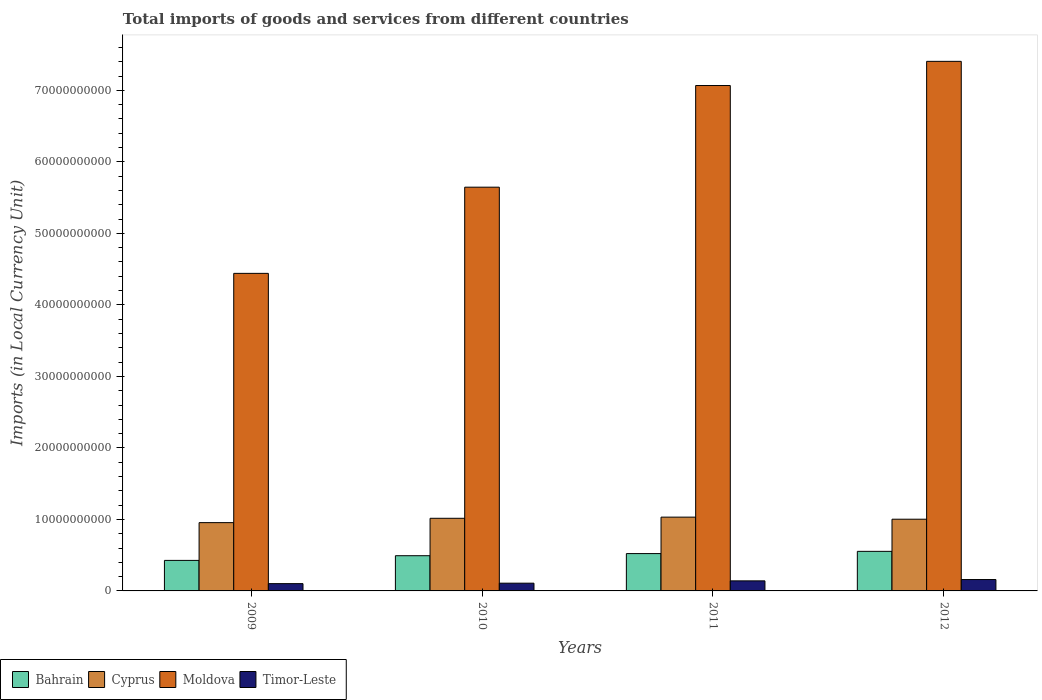How many different coloured bars are there?
Offer a terse response. 4. What is the label of the 1st group of bars from the left?
Your response must be concise. 2009. What is the Amount of goods and services imports in Bahrain in 2012?
Offer a very short reply. 5.53e+09. Across all years, what is the maximum Amount of goods and services imports in Bahrain?
Provide a short and direct response. 5.53e+09. Across all years, what is the minimum Amount of goods and services imports in Cyprus?
Make the answer very short. 9.55e+09. In which year was the Amount of goods and services imports in Bahrain maximum?
Ensure brevity in your answer.  2012. In which year was the Amount of goods and services imports in Timor-Leste minimum?
Your answer should be compact. 2009. What is the total Amount of goods and services imports in Bahrain in the graph?
Make the answer very short. 1.99e+1. What is the difference between the Amount of goods and services imports in Cyprus in 2011 and that in 2012?
Provide a short and direct response. 2.91e+08. What is the difference between the Amount of goods and services imports in Bahrain in 2011 and the Amount of goods and services imports in Timor-Leste in 2012?
Give a very brief answer. 3.63e+09. What is the average Amount of goods and services imports in Bahrain per year?
Your response must be concise. 4.99e+09. In the year 2011, what is the difference between the Amount of goods and services imports in Cyprus and Amount of goods and services imports in Bahrain?
Provide a succinct answer. 5.10e+09. In how many years, is the Amount of goods and services imports in Bahrain greater than 4000000000 LCU?
Give a very brief answer. 4. What is the ratio of the Amount of goods and services imports in Cyprus in 2009 to that in 2011?
Ensure brevity in your answer.  0.93. Is the Amount of goods and services imports in Timor-Leste in 2009 less than that in 2010?
Make the answer very short. Yes. Is the difference between the Amount of goods and services imports in Cyprus in 2010 and 2011 greater than the difference between the Amount of goods and services imports in Bahrain in 2010 and 2011?
Offer a terse response. Yes. What is the difference between the highest and the second highest Amount of goods and services imports in Cyprus?
Provide a short and direct response. 1.61e+08. What is the difference between the highest and the lowest Amount of goods and services imports in Cyprus?
Your answer should be very brief. 7.69e+08. Is it the case that in every year, the sum of the Amount of goods and services imports in Cyprus and Amount of goods and services imports in Timor-Leste is greater than the sum of Amount of goods and services imports in Bahrain and Amount of goods and services imports in Moldova?
Your response must be concise. Yes. What does the 3rd bar from the left in 2010 represents?
Your answer should be very brief. Moldova. What does the 4th bar from the right in 2010 represents?
Provide a short and direct response. Bahrain. Is it the case that in every year, the sum of the Amount of goods and services imports in Cyprus and Amount of goods and services imports in Moldova is greater than the Amount of goods and services imports in Timor-Leste?
Offer a terse response. Yes. Are all the bars in the graph horizontal?
Ensure brevity in your answer.  No. Are the values on the major ticks of Y-axis written in scientific E-notation?
Keep it short and to the point. No. How many legend labels are there?
Your response must be concise. 4. What is the title of the graph?
Your answer should be very brief. Total imports of goods and services from different countries. What is the label or title of the X-axis?
Your answer should be very brief. Years. What is the label or title of the Y-axis?
Make the answer very short. Imports (in Local Currency Unit). What is the Imports (in Local Currency Unit) of Bahrain in 2009?
Your answer should be very brief. 4.27e+09. What is the Imports (in Local Currency Unit) in Cyprus in 2009?
Ensure brevity in your answer.  9.55e+09. What is the Imports (in Local Currency Unit) of Moldova in 2009?
Offer a very short reply. 4.44e+1. What is the Imports (in Local Currency Unit) in Timor-Leste in 2009?
Keep it short and to the point. 1.02e+09. What is the Imports (in Local Currency Unit) in Bahrain in 2010?
Offer a very short reply. 4.92e+09. What is the Imports (in Local Currency Unit) in Cyprus in 2010?
Make the answer very short. 1.02e+1. What is the Imports (in Local Currency Unit) of Moldova in 2010?
Provide a short and direct response. 5.65e+1. What is the Imports (in Local Currency Unit) in Timor-Leste in 2010?
Keep it short and to the point. 1.08e+09. What is the Imports (in Local Currency Unit) of Bahrain in 2011?
Give a very brief answer. 5.22e+09. What is the Imports (in Local Currency Unit) of Cyprus in 2011?
Your answer should be compact. 1.03e+1. What is the Imports (in Local Currency Unit) in Moldova in 2011?
Make the answer very short. 7.07e+1. What is the Imports (in Local Currency Unit) in Timor-Leste in 2011?
Your answer should be compact. 1.41e+09. What is the Imports (in Local Currency Unit) in Bahrain in 2012?
Offer a terse response. 5.53e+09. What is the Imports (in Local Currency Unit) of Cyprus in 2012?
Make the answer very short. 1.00e+1. What is the Imports (in Local Currency Unit) in Moldova in 2012?
Your answer should be very brief. 7.41e+1. What is the Imports (in Local Currency Unit) of Timor-Leste in 2012?
Keep it short and to the point. 1.59e+09. Across all years, what is the maximum Imports (in Local Currency Unit) of Bahrain?
Provide a succinct answer. 5.53e+09. Across all years, what is the maximum Imports (in Local Currency Unit) in Cyprus?
Give a very brief answer. 1.03e+1. Across all years, what is the maximum Imports (in Local Currency Unit) in Moldova?
Offer a very short reply. 7.41e+1. Across all years, what is the maximum Imports (in Local Currency Unit) of Timor-Leste?
Provide a short and direct response. 1.59e+09. Across all years, what is the minimum Imports (in Local Currency Unit) in Bahrain?
Keep it short and to the point. 4.27e+09. Across all years, what is the minimum Imports (in Local Currency Unit) in Cyprus?
Offer a terse response. 9.55e+09. Across all years, what is the minimum Imports (in Local Currency Unit) in Moldova?
Give a very brief answer. 4.44e+1. Across all years, what is the minimum Imports (in Local Currency Unit) of Timor-Leste?
Give a very brief answer. 1.02e+09. What is the total Imports (in Local Currency Unit) of Bahrain in the graph?
Ensure brevity in your answer.  1.99e+1. What is the total Imports (in Local Currency Unit) in Cyprus in the graph?
Provide a short and direct response. 4.01e+1. What is the total Imports (in Local Currency Unit) of Moldova in the graph?
Provide a short and direct response. 2.46e+11. What is the total Imports (in Local Currency Unit) of Timor-Leste in the graph?
Keep it short and to the point. 5.10e+09. What is the difference between the Imports (in Local Currency Unit) of Bahrain in 2009 and that in 2010?
Keep it short and to the point. -6.55e+08. What is the difference between the Imports (in Local Currency Unit) of Cyprus in 2009 and that in 2010?
Provide a short and direct response. -6.08e+08. What is the difference between the Imports (in Local Currency Unit) in Moldova in 2009 and that in 2010?
Keep it short and to the point. -1.21e+1. What is the difference between the Imports (in Local Currency Unit) of Timor-Leste in 2009 and that in 2010?
Your answer should be very brief. -6.20e+07. What is the difference between the Imports (in Local Currency Unit) in Bahrain in 2009 and that in 2011?
Offer a terse response. -9.51e+08. What is the difference between the Imports (in Local Currency Unit) in Cyprus in 2009 and that in 2011?
Offer a very short reply. -7.69e+08. What is the difference between the Imports (in Local Currency Unit) of Moldova in 2009 and that in 2011?
Ensure brevity in your answer.  -2.63e+1. What is the difference between the Imports (in Local Currency Unit) of Timor-Leste in 2009 and that in 2011?
Your answer should be compact. -3.86e+08. What is the difference between the Imports (in Local Currency Unit) of Bahrain in 2009 and that in 2012?
Your response must be concise. -1.27e+09. What is the difference between the Imports (in Local Currency Unit) of Cyprus in 2009 and that in 2012?
Your answer should be compact. -4.78e+08. What is the difference between the Imports (in Local Currency Unit) in Moldova in 2009 and that in 2012?
Offer a terse response. -2.96e+1. What is the difference between the Imports (in Local Currency Unit) of Timor-Leste in 2009 and that in 2012?
Offer a very short reply. -5.72e+08. What is the difference between the Imports (in Local Currency Unit) of Bahrain in 2010 and that in 2011?
Your response must be concise. -2.96e+08. What is the difference between the Imports (in Local Currency Unit) of Cyprus in 2010 and that in 2011?
Your answer should be very brief. -1.61e+08. What is the difference between the Imports (in Local Currency Unit) of Moldova in 2010 and that in 2011?
Provide a succinct answer. -1.42e+1. What is the difference between the Imports (in Local Currency Unit) in Timor-Leste in 2010 and that in 2011?
Your answer should be compact. -3.24e+08. What is the difference between the Imports (in Local Currency Unit) of Bahrain in 2010 and that in 2012?
Give a very brief answer. -6.10e+08. What is the difference between the Imports (in Local Currency Unit) in Cyprus in 2010 and that in 2012?
Keep it short and to the point. 1.30e+08. What is the difference between the Imports (in Local Currency Unit) of Moldova in 2010 and that in 2012?
Keep it short and to the point. -1.76e+1. What is the difference between the Imports (in Local Currency Unit) of Timor-Leste in 2010 and that in 2012?
Offer a terse response. -5.10e+08. What is the difference between the Imports (in Local Currency Unit) in Bahrain in 2011 and that in 2012?
Your answer should be very brief. -3.14e+08. What is the difference between the Imports (in Local Currency Unit) in Cyprus in 2011 and that in 2012?
Provide a short and direct response. 2.91e+08. What is the difference between the Imports (in Local Currency Unit) of Moldova in 2011 and that in 2012?
Make the answer very short. -3.38e+09. What is the difference between the Imports (in Local Currency Unit) in Timor-Leste in 2011 and that in 2012?
Provide a succinct answer. -1.86e+08. What is the difference between the Imports (in Local Currency Unit) of Bahrain in 2009 and the Imports (in Local Currency Unit) of Cyprus in 2010?
Your response must be concise. -5.89e+09. What is the difference between the Imports (in Local Currency Unit) of Bahrain in 2009 and the Imports (in Local Currency Unit) of Moldova in 2010?
Offer a very short reply. -5.22e+1. What is the difference between the Imports (in Local Currency Unit) in Bahrain in 2009 and the Imports (in Local Currency Unit) in Timor-Leste in 2010?
Make the answer very short. 3.19e+09. What is the difference between the Imports (in Local Currency Unit) in Cyprus in 2009 and the Imports (in Local Currency Unit) in Moldova in 2010?
Keep it short and to the point. -4.69e+1. What is the difference between the Imports (in Local Currency Unit) in Cyprus in 2009 and the Imports (in Local Currency Unit) in Timor-Leste in 2010?
Provide a succinct answer. 8.47e+09. What is the difference between the Imports (in Local Currency Unit) in Moldova in 2009 and the Imports (in Local Currency Unit) in Timor-Leste in 2010?
Offer a very short reply. 4.33e+1. What is the difference between the Imports (in Local Currency Unit) of Bahrain in 2009 and the Imports (in Local Currency Unit) of Cyprus in 2011?
Provide a short and direct response. -6.05e+09. What is the difference between the Imports (in Local Currency Unit) of Bahrain in 2009 and the Imports (in Local Currency Unit) of Moldova in 2011?
Make the answer very short. -6.64e+1. What is the difference between the Imports (in Local Currency Unit) of Bahrain in 2009 and the Imports (in Local Currency Unit) of Timor-Leste in 2011?
Your answer should be compact. 2.86e+09. What is the difference between the Imports (in Local Currency Unit) of Cyprus in 2009 and the Imports (in Local Currency Unit) of Moldova in 2011?
Make the answer very short. -6.11e+1. What is the difference between the Imports (in Local Currency Unit) of Cyprus in 2009 and the Imports (in Local Currency Unit) of Timor-Leste in 2011?
Ensure brevity in your answer.  8.14e+09. What is the difference between the Imports (in Local Currency Unit) of Moldova in 2009 and the Imports (in Local Currency Unit) of Timor-Leste in 2011?
Offer a terse response. 4.30e+1. What is the difference between the Imports (in Local Currency Unit) of Bahrain in 2009 and the Imports (in Local Currency Unit) of Cyprus in 2012?
Provide a short and direct response. -5.76e+09. What is the difference between the Imports (in Local Currency Unit) in Bahrain in 2009 and the Imports (in Local Currency Unit) in Moldova in 2012?
Provide a short and direct response. -6.98e+1. What is the difference between the Imports (in Local Currency Unit) in Bahrain in 2009 and the Imports (in Local Currency Unit) in Timor-Leste in 2012?
Offer a very short reply. 2.68e+09. What is the difference between the Imports (in Local Currency Unit) in Cyprus in 2009 and the Imports (in Local Currency Unit) in Moldova in 2012?
Offer a terse response. -6.45e+1. What is the difference between the Imports (in Local Currency Unit) of Cyprus in 2009 and the Imports (in Local Currency Unit) of Timor-Leste in 2012?
Keep it short and to the point. 7.96e+09. What is the difference between the Imports (in Local Currency Unit) in Moldova in 2009 and the Imports (in Local Currency Unit) in Timor-Leste in 2012?
Keep it short and to the point. 4.28e+1. What is the difference between the Imports (in Local Currency Unit) in Bahrain in 2010 and the Imports (in Local Currency Unit) in Cyprus in 2011?
Your response must be concise. -5.39e+09. What is the difference between the Imports (in Local Currency Unit) of Bahrain in 2010 and the Imports (in Local Currency Unit) of Moldova in 2011?
Your answer should be very brief. -6.58e+1. What is the difference between the Imports (in Local Currency Unit) in Bahrain in 2010 and the Imports (in Local Currency Unit) in Timor-Leste in 2011?
Keep it short and to the point. 3.52e+09. What is the difference between the Imports (in Local Currency Unit) in Cyprus in 2010 and the Imports (in Local Currency Unit) in Moldova in 2011?
Your answer should be compact. -6.05e+1. What is the difference between the Imports (in Local Currency Unit) of Cyprus in 2010 and the Imports (in Local Currency Unit) of Timor-Leste in 2011?
Keep it short and to the point. 8.75e+09. What is the difference between the Imports (in Local Currency Unit) of Moldova in 2010 and the Imports (in Local Currency Unit) of Timor-Leste in 2011?
Make the answer very short. 5.51e+1. What is the difference between the Imports (in Local Currency Unit) of Bahrain in 2010 and the Imports (in Local Currency Unit) of Cyprus in 2012?
Give a very brief answer. -5.10e+09. What is the difference between the Imports (in Local Currency Unit) in Bahrain in 2010 and the Imports (in Local Currency Unit) in Moldova in 2012?
Provide a succinct answer. -6.91e+1. What is the difference between the Imports (in Local Currency Unit) of Bahrain in 2010 and the Imports (in Local Currency Unit) of Timor-Leste in 2012?
Make the answer very short. 3.33e+09. What is the difference between the Imports (in Local Currency Unit) of Cyprus in 2010 and the Imports (in Local Currency Unit) of Moldova in 2012?
Your answer should be very brief. -6.39e+1. What is the difference between the Imports (in Local Currency Unit) of Cyprus in 2010 and the Imports (in Local Currency Unit) of Timor-Leste in 2012?
Provide a short and direct response. 8.57e+09. What is the difference between the Imports (in Local Currency Unit) of Moldova in 2010 and the Imports (in Local Currency Unit) of Timor-Leste in 2012?
Give a very brief answer. 5.49e+1. What is the difference between the Imports (in Local Currency Unit) of Bahrain in 2011 and the Imports (in Local Currency Unit) of Cyprus in 2012?
Make the answer very short. -4.81e+09. What is the difference between the Imports (in Local Currency Unit) of Bahrain in 2011 and the Imports (in Local Currency Unit) of Moldova in 2012?
Your answer should be very brief. -6.88e+1. What is the difference between the Imports (in Local Currency Unit) of Bahrain in 2011 and the Imports (in Local Currency Unit) of Timor-Leste in 2012?
Your answer should be compact. 3.63e+09. What is the difference between the Imports (in Local Currency Unit) of Cyprus in 2011 and the Imports (in Local Currency Unit) of Moldova in 2012?
Make the answer very short. -6.37e+1. What is the difference between the Imports (in Local Currency Unit) of Cyprus in 2011 and the Imports (in Local Currency Unit) of Timor-Leste in 2012?
Give a very brief answer. 8.73e+09. What is the difference between the Imports (in Local Currency Unit) of Moldova in 2011 and the Imports (in Local Currency Unit) of Timor-Leste in 2012?
Ensure brevity in your answer.  6.91e+1. What is the average Imports (in Local Currency Unit) of Bahrain per year?
Ensure brevity in your answer.  4.99e+09. What is the average Imports (in Local Currency Unit) in Cyprus per year?
Keep it short and to the point. 1.00e+1. What is the average Imports (in Local Currency Unit) of Moldova per year?
Offer a very short reply. 6.14e+1. What is the average Imports (in Local Currency Unit) of Timor-Leste per year?
Give a very brief answer. 1.28e+09. In the year 2009, what is the difference between the Imports (in Local Currency Unit) in Bahrain and Imports (in Local Currency Unit) in Cyprus?
Keep it short and to the point. -5.28e+09. In the year 2009, what is the difference between the Imports (in Local Currency Unit) in Bahrain and Imports (in Local Currency Unit) in Moldova?
Offer a terse response. -4.01e+1. In the year 2009, what is the difference between the Imports (in Local Currency Unit) of Bahrain and Imports (in Local Currency Unit) of Timor-Leste?
Make the answer very short. 3.25e+09. In the year 2009, what is the difference between the Imports (in Local Currency Unit) in Cyprus and Imports (in Local Currency Unit) in Moldova?
Keep it short and to the point. -3.49e+1. In the year 2009, what is the difference between the Imports (in Local Currency Unit) in Cyprus and Imports (in Local Currency Unit) in Timor-Leste?
Your answer should be very brief. 8.53e+09. In the year 2009, what is the difference between the Imports (in Local Currency Unit) in Moldova and Imports (in Local Currency Unit) in Timor-Leste?
Your answer should be very brief. 4.34e+1. In the year 2010, what is the difference between the Imports (in Local Currency Unit) of Bahrain and Imports (in Local Currency Unit) of Cyprus?
Your answer should be very brief. -5.23e+09. In the year 2010, what is the difference between the Imports (in Local Currency Unit) of Bahrain and Imports (in Local Currency Unit) of Moldova?
Give a very brief answer. -5.15e+1. In the year 2010, what is the difference between the Imports (in Local Currency Unit) in Bahrain and Imports (in Local Currency Unit) in Timor-Leste?
Provide a succinct answer. 3.84e+09. In the year 2010, what is the difference between the Imports (in Local Currency Unit) of Cyprus and Imports (in Local Currency Unit) of Moldova?
Your answer should be very brief. -4.63e+1. In the year 2010, what is the difference between the Imports (in Local Currency Unit) in Cyprus and Imports (in Local Currency Unit) in Timor-Leste?
Your answer should be very brief. 9.08e+09. In the year 2010, what is the difference between the Imports (in Local Currency Unit) of Moldova and Imports (in Local Currency Unit) of Timor-Leste?
Give a very brief answer. 5.54e+1. In the year 2011, what is the difference between the Imports (in Local Currency Unit) of Bahrain and Imports (in Local Currency Unit) of Cyprus?
Provide a short and direct response. -5.10e+09. In the year 2011, what is the difference between the Imports (in Local Currency Unit) in Bahrain and Imports (in Local Currency Unit) in Moldova?
Ensure brevity in your answer.  -6.55e+1. In the year 2011, what is the difference between the Imports (in Local Currency Unit) of Bahrain and Imports (in Local Currency Unit) of Timor-Leste?
Keep it short and to the point. 3.81e+09. In the year 2011, what is the difference between the Imports (in Local Currency Unit) of Cyprus and Imports (in Local Currency Unit) of Moldova?
Offer a terse response. -6.04e+1. In the year 2011, what is the difference between the Imports (in Local Currency Unit) of Cyprus and Imports (in Local Currency Unit) of Timor-Leste?
Give a very brief answer. 8.91e+09. In the year 2011, what is the difference between the Imports (in Local Currency Unit) of Moldova and Imports (in Local Currency Unit) of Timor-Leste?
Your answer should be compact. 6.93e+1. In the year 2012, what is the difference between the Imports (in Local Currency Unit) of Bahrain and Imports (in Local Currency Unit) of Cyprus?
Your answer should be compact. -4.49e+09. In the year 2012, what is the difference between the Imports (in Local Currency Unit) of Bahrain and Imports (in Local Currency Unit) of Moldova?
Make the answer very short. -6.85e+1. In the year 2012, what is the difference between the Imports (in Local Currency Unit) of Bahrain and Imports (in Local Currency Unit) of Timor-Leste?
Your answer should be compact. 3.94e+09. In the year 2012, what is the difference between the Imports (in Local Currency Unit) in Cyprus and Imports (in Local Currency Unit) in Moldova?
Offer a very short reply. -6.40e+1. In the year 2012, what is the difference between the Imports (in Local Currency Unit) of Cyprus and Imports (in Local Currency Unit) of Timor-Leste?
Your response must be concise. 8.44e+09. In the year 2012, what is the difference between the Imports (in Local Currency Unit) in Moldova and Imports (in Local Currency Unit) in Timor-Leste?
Keep it short and to the point. 7.25e+1. What is the ratio of the Imports (in Local Currency Unit) of Bahrain in 2009 to that in 2010?
Offer a terse response. 0.87. What is the ratio of the Imports (in Local Currency Unit) of Cyprus in 2009 to that in 2010?
Provide a succinct answer. 0.94. What is the ratio of the Imports (in Local Currency Unit) in Moldova in 2009 to that in 2010?
Ensure brevity in your answer.  0.79. What is the ratio of the Imports (in Local Currency Unit) in Timor-Leste in 2009 to that in 2010?
Provide a short and direct response. 0.94. What is the ratio of the Imports (in Local Currency Unit) in Bahrain in 2009 to that in 2011?
Keep it short and to the point. 0.82. What is the ratio of the Imports (in Local Currency Unit) of Cyprus in 2009 to that in 2011?
Provide a short and direct response. 0.93. What is the ratio of the Imports (in Local Currency Unit) in Moldova in 2009 to that in 2011?
Make the answer very short. 0.63. What is the ratio of the Imports (in Local Currency Unit) in Timor-Leste in 2009 to that in 2011?
Provide a succinct answer. 0.73. What is the ratio of the Imports (in Local Currency Unit) in Bahrain in 2009 to that in 2012?
Your answer should be compact. 0.77. What is the ratio of the Imports (in Local Currency Unit) of Cyprus in 2009 to that in 2012?
Offer a very short reply. 0.95. What is the ratio of the Imports (in Local Currency Unit) of Moldova in 2009 to that in 2012?
Keep it short and to the point. 0.6. What is the ratio of the Imports (in Local Currency Unit) of Timor-Leste in 2009 to that in 2012?
Provide a succinct answer. 0.64. What is the ratio of the Imports (in Local Currency Unit) in Bahrain in 2010 to that in 2011?
Your response must be concise. 0.94. What is the ratio of the Imports (in Local Currency Unit) of Cyprus in 2010 to that in 2011?
Your response must be concise. 0.98. What is the ratio of the Imports (in Local Currency Unit) in Moldova in 2010 to that in 2011?
Make the answer very short. 0.8. What is the ratio of the Imports (in Local Currency Unit) in Timor-Leste in 2010 to that in 2011?
Provide a succinct answer. 0.77. What is the ratio of the Imports (in Local Currency Unit) in Bahrain in 2010 to that in 2012?
Your answer should be compact. 0.89. What is the ratio of the Imports (in Local Currency Unit) of Cyprus in 2010 to that in 2012?
Your answer should be very brief. 1.01. What is the ratio of the Imports (in Local Currency Unit) in Moldova in 2010 to that in 2012?
Your response must be concise. 0.76. What is the ratio of the Imports (in Local Currency Unit) of Timor-Leste in 2010 to that in 2012?
Ensure brevity in your answer.  0.68. What is the ratio of the Imports (in Local Currency Unit) in Bahrain in 2011 to that in 2012?
Provide a succinct answer. 0.94. What is the ratio of the Imports (in Local Currency Unit) of Moldova in 2011 to that in 2012?
Offer a terse response. 0.95. What is the ratio of the Imports (in Local Currency Unit) of Timor-Leste in 2011 to that in 2012?
Your answer should be compact. 0.88. What is the difference between the highest and the second highest Imports (in Local Currency Unit) in Bahrain?
Ensure brevity in your answer.  3.14e+08. What is the difference between the highest and the second highest Imports (in Local Currency Unit) of Cyprus?
Keep it short and to the point. 1.61e+08. What is the difference between the highest and the second highest Imports (in Local Currency Unit) of Moldova?
Ensure brevity in your answer.  3.38e+09. What is the difference between the highest and the second highest Imports (in Local Currency Unit) of Timor-Leste?
Offer a terse response. 1.86e+08. What is the difference between the highest and the lowest Imports (in Local Currency Unit) of Bahrain?
Your answer should be very brief. 1.27e+09. What is the difference between the highest and the lowest Imports (in Local Currency Unit) in Cyprus?
Keep it short and to the point. 7.69e+08. What is the difference between the highest and the lowest Imports (in Local Currency Unit) of Moldova?
Ensure brevity in your answer.  2.96e+1. What is the difference between the highest and the lowest Imports (in Local Currency Unit) of Timor-Leste?
Offer a very short reply. 5.72e+08. 